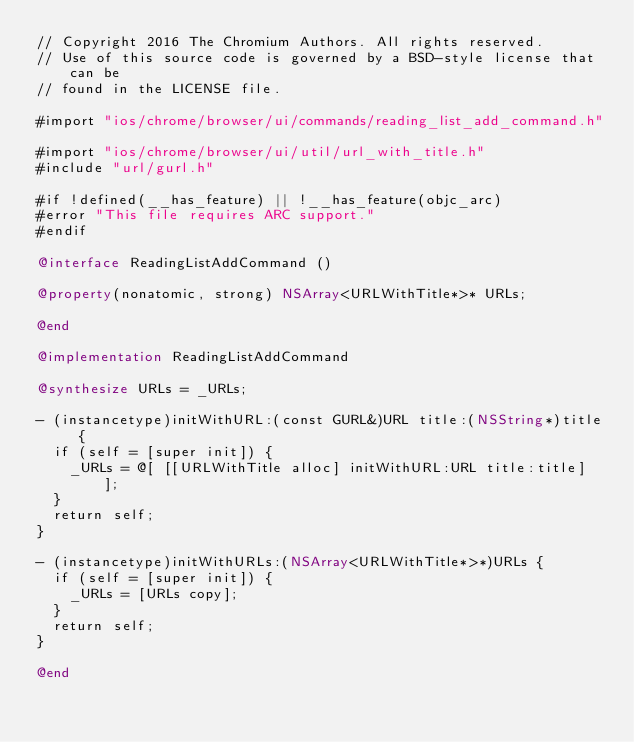<code> <loc_0><loc_0><loc_500><loc_500><_ObjectiveC_>// Copyright 2016 The Chromium Authors. All rights reserved.
// Use of this source code is governed by a BSD-style license that can be
// found in the LICENSE file.

#import "ios/chrome/browser/ui/commands/reading_list_add_command.h"

#import "ios/chrome/browser/ui/util/url_with_title.h"
#include "url/gurl.h"

#if !defined(__has_feature) || !__has_feature(objc_arc)
#error "This file requires ARC support."
#endif

@interface ReadingListAddCommand ()

@property(nonatomic, strong) NSArray<URLWithTitle*>* URLs;

@end

@implementation ReadingListAddCommand

@synthesize URLs = _URLs;

- (instancetype)initWithURL:(const GURL&)URL title:(NSString*)title {
  if (self = [super init]) {
    _URLs = @[ [[URLWithTitle alloc] initWithURL:URL title:title] ];
  }
  return self;
}

- (instancetype)initWithURLs:(NSArray<URLWithTitle*>*)URLs {
  if (self = [super init]) {
    _URLs = [URLs copy];
  }
  return self;
}

@end
</code> 